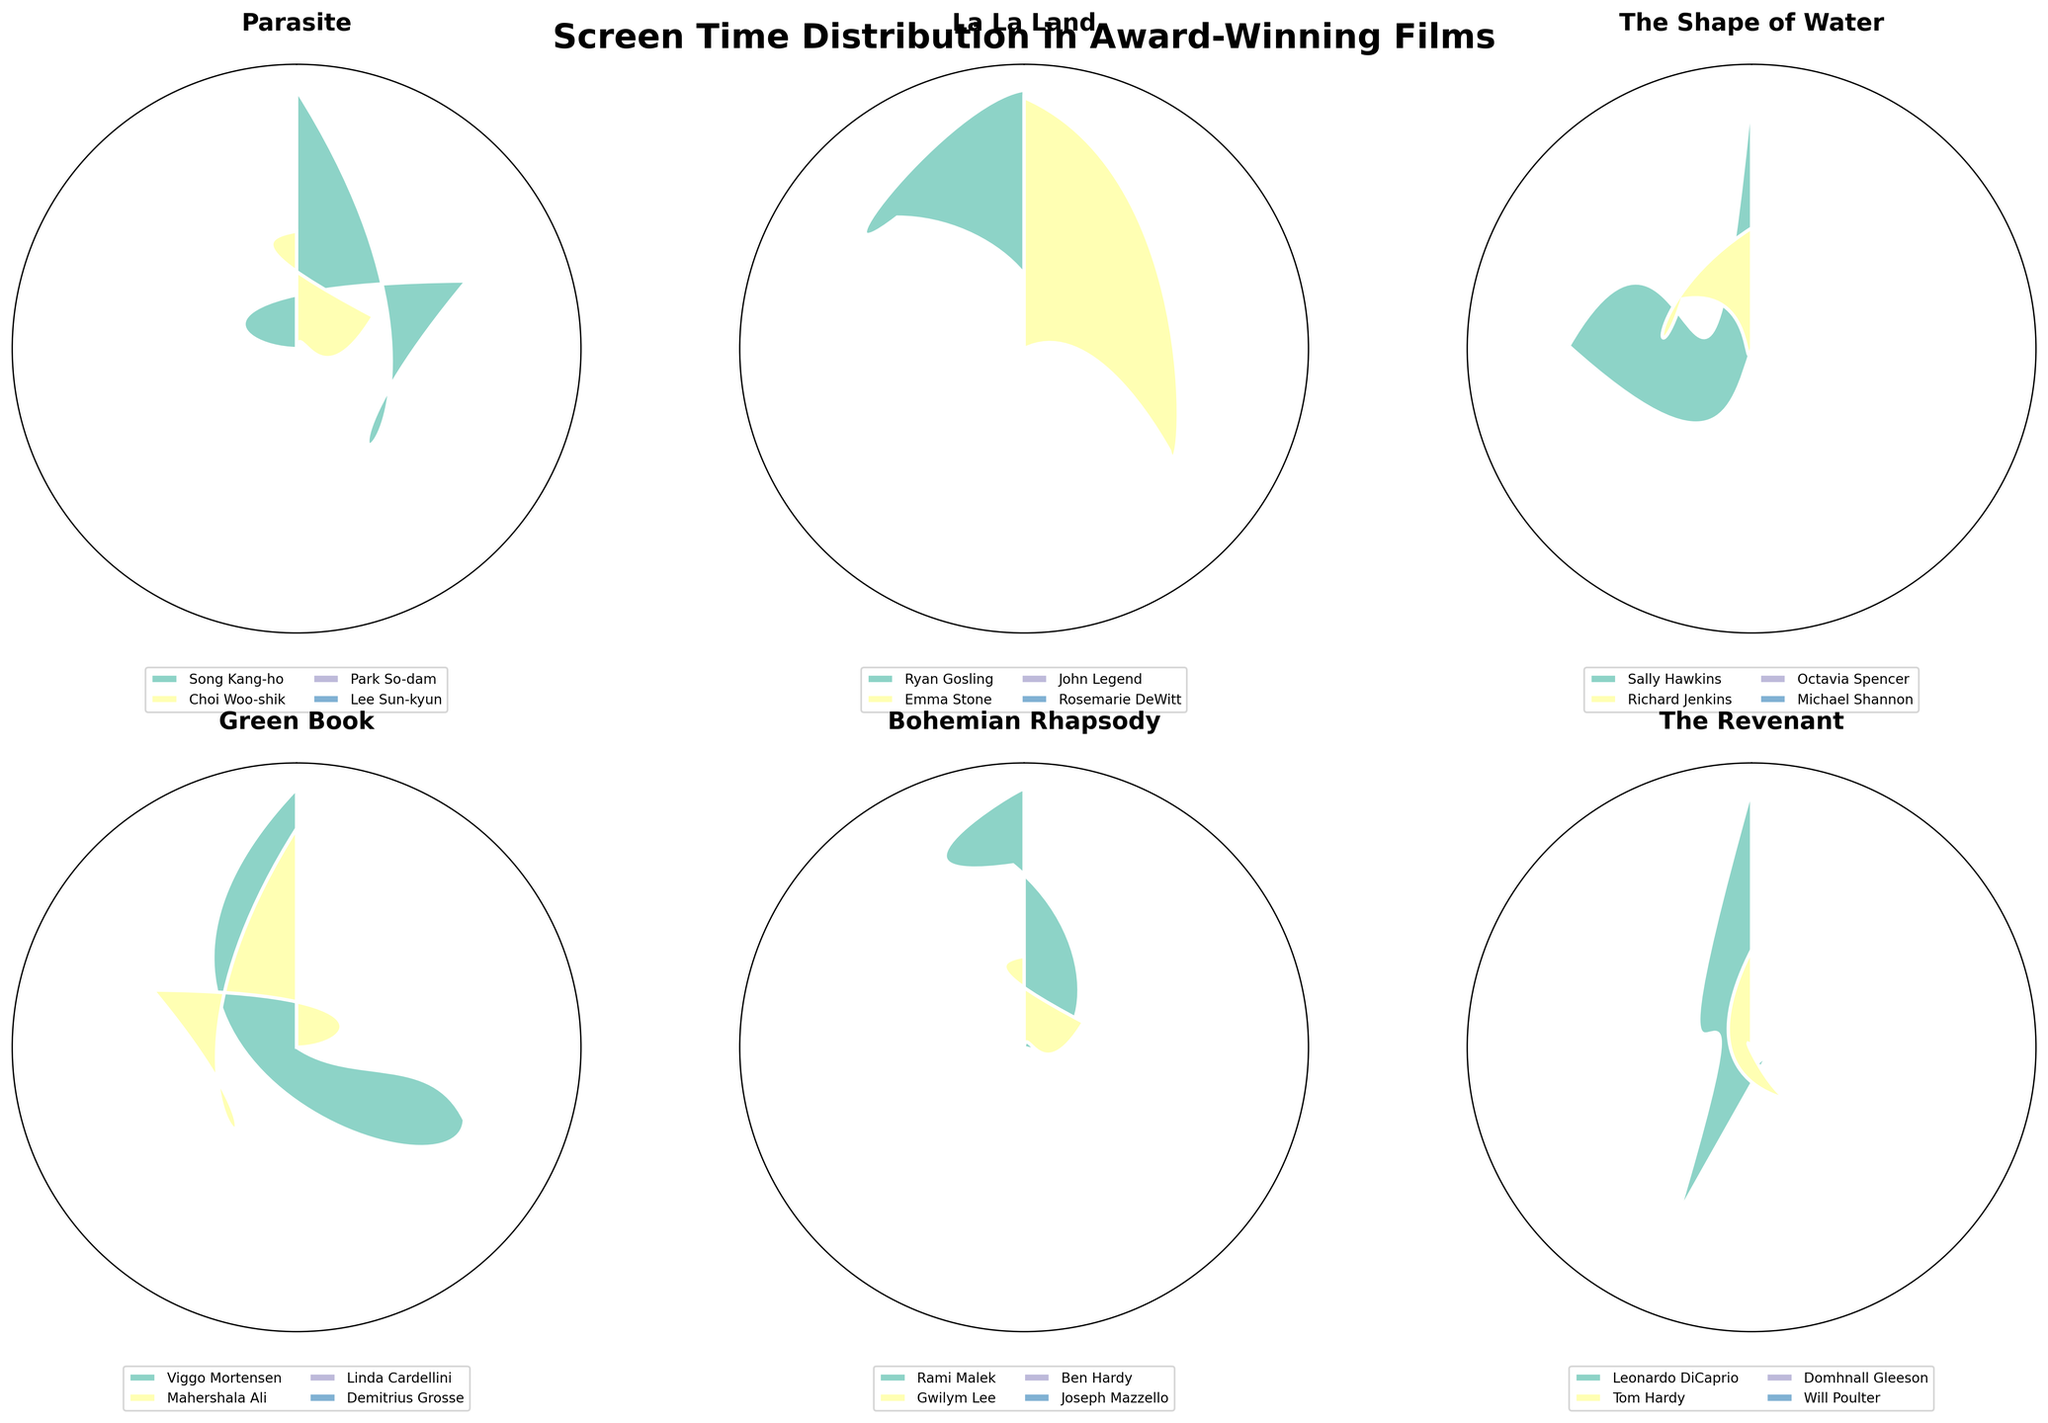What's the title of the figure? The title of the figure is written at the top center. It reads "Screen Time Distribution in Award-Winning Films".
Answer: Screen Time Distribution in Award-Winning Films How many films are represented in the figure? Count the number of subplots, as each subplot represents one film. There are six subplots in total.
Answer: Six Which film has the actor with the highest screen time, and what is this screen time? Identify the subplot with the highest bar. This belongs to "The Revenant", and the actor is Leonardo DiCaprio with 85 minutes of screen time.
Answer: The Revenant, 85 minutes Which actor has the highest screen time in "La La Land"? Look at the "La La Land" subplot and identify the actor with the largest portion of the chart. Both Ryan Gosling and Emma Stone have very similar screen times, but Ryan Gosling slightly edges with 70 minutes.
Answer: Ryan Gosling Compare the screen times of the main actors in "Parasite". Which one has the highest, and by how much does it exceed the supporting actors? In the "Parasite" subplot, the main actor is Song Kang-ho with 55 minutes. The highest supporting actor has a screen time of 25 minutes (Choi Woo-shik). So the difference is 55 – 25 = 30 minutes.
Answer: Song Kang-ho, 30 minutes Which film has the most balanced screen time distribution between its main and supporting actors? Observe the subplots and see which one has segments of relatively equal size. "The Shape of Water" looks quite balanced between its main actor Sally Hawkins and supporting actors Richard Jenkins, Octavia Spencer, and Michael Shannon.
Answer: The Shape of Water What is the combined screen time of the main actors in "Bohemian Rhapsody"? In the "Bohemian Rhapsody" subplot, the main actor is Rami Malek with 71 minutes. Since there's only one main actor, the combined screen time is simply Rami Malek's screen time.
Answer: 71 minutes How does the screen time of Sally Hawkins in "The Shape of Water" compare to Viggo Mortensen in "Green Book"? Sally Hawkins has 60 minutes of screen time, while Viggo Mortensen has 65 minutes. Therefore, Viggo Mortensen has 5 more minutes of screen time.
Answer: Viggo Mortensen by 5 minutes In "The Revenant", what is the combined screen time of all supporting actors? Summing the screen times of all supporting actors in "The Revenant": Tom Hardy (32 minutes), Domhnall Gleeson (18 minutes), and Will Poulter (21 minutes). The total is 32 + 18 + 21 = 71 minutes.
Answer: 71 minutes 